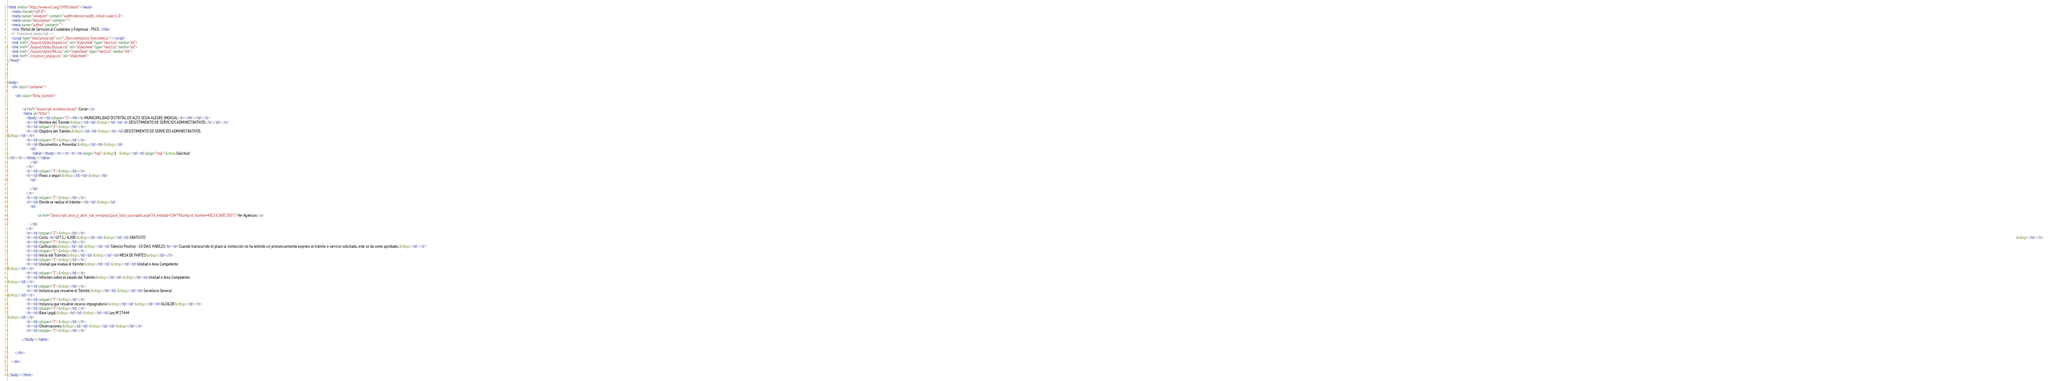<code> <loc_0><loc_0><loc_500><loc_500><_HTML_><html xmlns="http://www.w3.org/1999/xhtml"><head>
    <meta charset="utf-8">
    <meta name="viewport" content="width=device-width, initial-scale=1.0">
    <meta name="description" content="">
    <meta name="author" content="">
    <title>Portal de Servicios al Ciudadano y Empresas - PSCE</title>
    <!-- Funciones Javascript -->
    <script type="text/javascript" src="../funciones/psce_funciones.js"></script>
    <link href="../layout/styles/layout.css" rel="stylesheet" type="text/css" media="all"> 
    <link href="../layout/styles/buscar.css" rel="stylesheet" type="text/css" media="all"> 
    <link href="../layout/styles/fot.css" rel="stylesheet" type="text/css" media="all"> 
    <link href="../css/psce_popup.css" rel="stylesheet">
</head>

 


<body>
    <div class="container">

        <div class="ficha_tramite">

            
                <a href="Javascript: window.close()">Cerrar</a>
                <table id="ficha">
                    <tbody><tr><td colspan="3"><h4><b>MUNICIPALIDAD DISTRITAL DE ALTO SELVA ALEGRE (MDASA)</b></h4></td></tr>
                    <tr><td>Nombre del Trámite:&nbsp;</td><td>&nbsp;</td><td><b>DESISTIMIENTO DE SERVICIOS ADMINISTRATIVOS</b></td></tr>
                    <tr><td colspan="3">&nbsp;</td></tr>
                    <tr><td>Objetivo del Trámite:&nbsp;</td><td>&nbsp;</td><td>DESISTIMIENTO DE SERVICIOS ADMINISTRATIVOS
&nbsp;</td></tr>
                    <tr><td colspan="3">&nbsp;</td></tr>
                    <tr><td>Documentos a Presentar:&nbsp;</td><td>&nbsp;</td>
                        <td>
                          <table><tbody><tr></tr><tr><td valign="top">&nbsp;1   &nbsp;</td><td valign="top">&nbsp;Solicitud
</td></tr></tbody></table>
                        </td>
                    </tr>
                    <tr><td colspan="3">&nbsp;</td></tr>
                    <tr><td>Pasos a seguir:&nbsp;</td><td>&nbsp;</td>
                        <td>
                            
                        </td>
                    </tr>
                    <tr><td colspan="3">&nbsp;</td></tr>
                    <tr><td>Donde se realiza el trámite:</td><td>&nbsp;</td>
                        <td>
                            
                                <a href="Javascript: psce_js_abrir_sub_ventanas('psce_lista_sucursales.aspx?id_entidad=10479&amp;id_tramite=48216','600','500')">Ver Agencias</a>
                            
                        </td>
                    </tr>   
                    <tr><td colspan="3">&nbsp;</td></tr>
                    <tr><td>Costo <br>UIT S./ 4,200:&nbsp;</td><td>&nbsp;</td><td>GRATUITO                                                                                                                                                                                                                                                                                                                                                                                                                                                                                                                                                                                                                                                                                                                                                                                                                                                                                                                                                                                                                                                                                                                                                                                                                                                                                                                                                                                                                                                                                                                                                                                                                                                                                                                                                                                                                                                                                                                                                                                                                                                                        &nbsp;</td></tr>
                    <tr><td colspan="3">&nbsp;</td></tr>
                    <tr><td>Calificación:&nbsp;</td><td>&nbsp;</td><td>Silencio Positivo - 10 DIAS HABILES<br><br>Cuando transcurrido el plazo la institución no ha emitido un pronunciamiento expreso al trámite o servicio solicitado, este se da como aprobado.&nbsp;</td></tr>
                    <tr><td colspan="3">&nbsp;</td></tr>
                    <tr><td>Inicio del Trámite:&nbsp;</td><td>&nbsp;</td><td>MESA DE PARTES&nbsp;</td></tr>
                    <tr><td colspan="3">&nbsp;</td></tr>
                    <tr><td>Unidad que evalúa el trámite:&nbsp;</td><td>&nbsp;</td><td>Unidad o Area Competente
&nbsp;</td></tr>
                    <tr><td colspan="3">&nbsp;</td></tr>
                    <tr><td>Informes sobre el estado del Trámite:&nbsp;</td><td>&nbsp;</td><td>Unidad o Area Competente
&nbsp;</td></tr>
                    <tr><td colspan="3">&nbsp;</td></tr>
                    <tr><td>Instancia que resuelve el Trámite:&nbsp;</td><td>&nbsp;</td><td>Secretario General
&nbsp;</td></tr>
                    <tr><td colspan="3">&nbsp;</td></tr>
                    <tr><td>Instancia que resuelve recurso impugnatorio:&nbsp;</td><td>&nbsp;</td><td>ALCALDE&nbsp;</td></tr>
                    <tr><td colspan="3">&nbsp;</td></tr>
                    <tr><td>Base Legal:&nbsp;</td><td>&nbsp;</td><td>Ley Nº27444
&nbsp;</td></tr>
                    <tr><td colspan="3">&nbsp;</td></tr>
                    <tr><td>Observaciones:&nbsp;</td><td>&nbsp;</td><td>&nbsp;</td></tr>
                    <tr><td colspan="3">&nbsp;</td></tr>

               </tbody></table>
            
            
        </div>

    </div>


</body></html></code> 